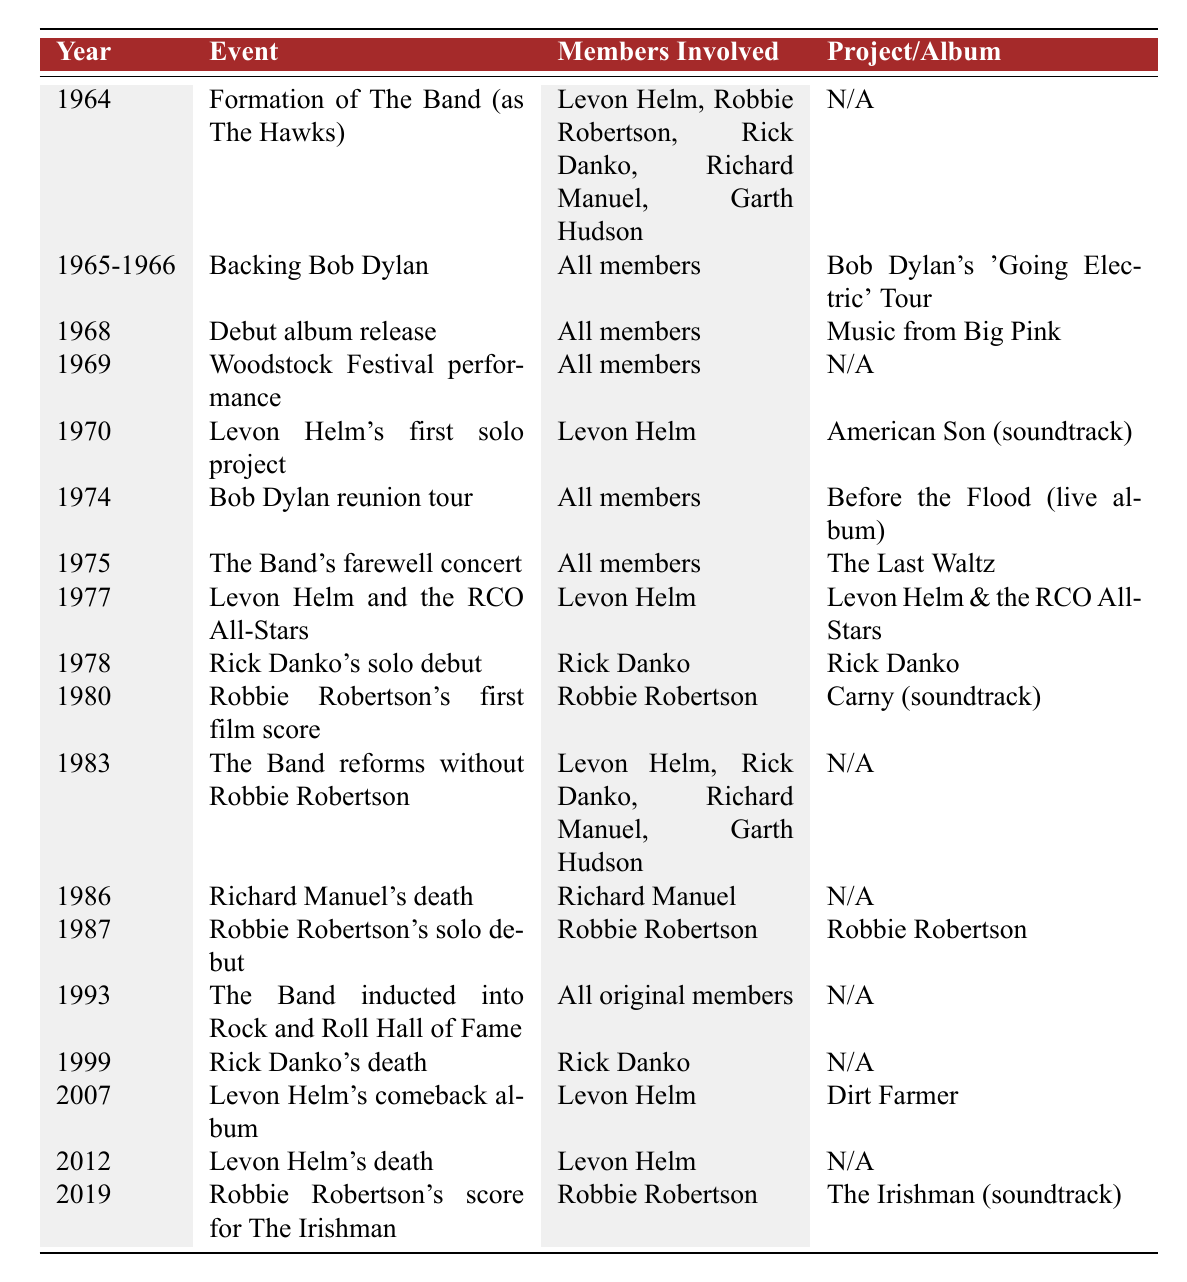What year did The Band release their debut album? The table lists "1968" as the year when The Band released their debut album "Music from Big Pink."
Answer: 1968 Which project involved all members of The Band in 1965-1966? According to the table, during 1965-1966, all members were involved in backing Bob Dylan as part of Bob Dylan's 'Going Electric' Tour.
Answer: Bob Dylan's 'Going Electric' Tour When did Levon Helm release his first solo project? The table shows that Levon Helm released his first solo project in 1970, named "American Son" (soundtrack).
Answer: 1970 How many years after their formation did The Band perform at Woodstock? The Band was formed in 1964 and performed at Woodstock in 1969. The difference is 5 years (1969 - 1964 = 5).
Answer: 5 years What is the name of the last project listed in the table? The most recent project in the table is "The Irishman" (soundtrack), released in 2019 by Robbie Robertson.
Answer: The Irishman (soundtrack) Did any member of The Band release a solo project in the same year as Richard Manuel's death? Richard Manuel died in 1986, and in that year, the table indicates that there were no solo projects released; hence, the answer is no.
Answer: No Which members were involved in the Band's farewell concert? The table notes that all members participated in The Band's farewell concert titled "The Last Waltz" in 1975.
Answer: All members How many members of The Band are listed as involved in projects after 1980? Examining the table reveals that Levon Helm, Rick Danko, and Robbie Robertson are the members involved in projects after 1980, making a total of 3 members.
Answer: 3 members Was there a year where a member's solo project coincided with a significant event (like death)? Yes, Richard Manuel's death occurred in 1986, but no solo project is listed that year; thus, while there is a significant event, there is no solo project coinciding.
Answer: Yes, but no solo project What was unique about The Band's lineup in 1983? The table indicates that in 1983, The Band reformed without Robbie Robertson, which is unique as this was the first time he was not involved.
Answer: They reformed without Robbie Robertson 